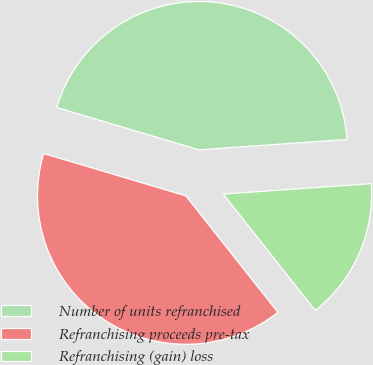Convert chart. <chart><loc_0><loc_0><loc_500><loc_500><pie_chart><fcel>Number of units refranchised<fcel>Refranchising proceeds pre-tax<fcel>Refranchising (gain) loss<nl><fcel>44.27%<fcel>40.25%<fcel>15.48%<nl></chart> 